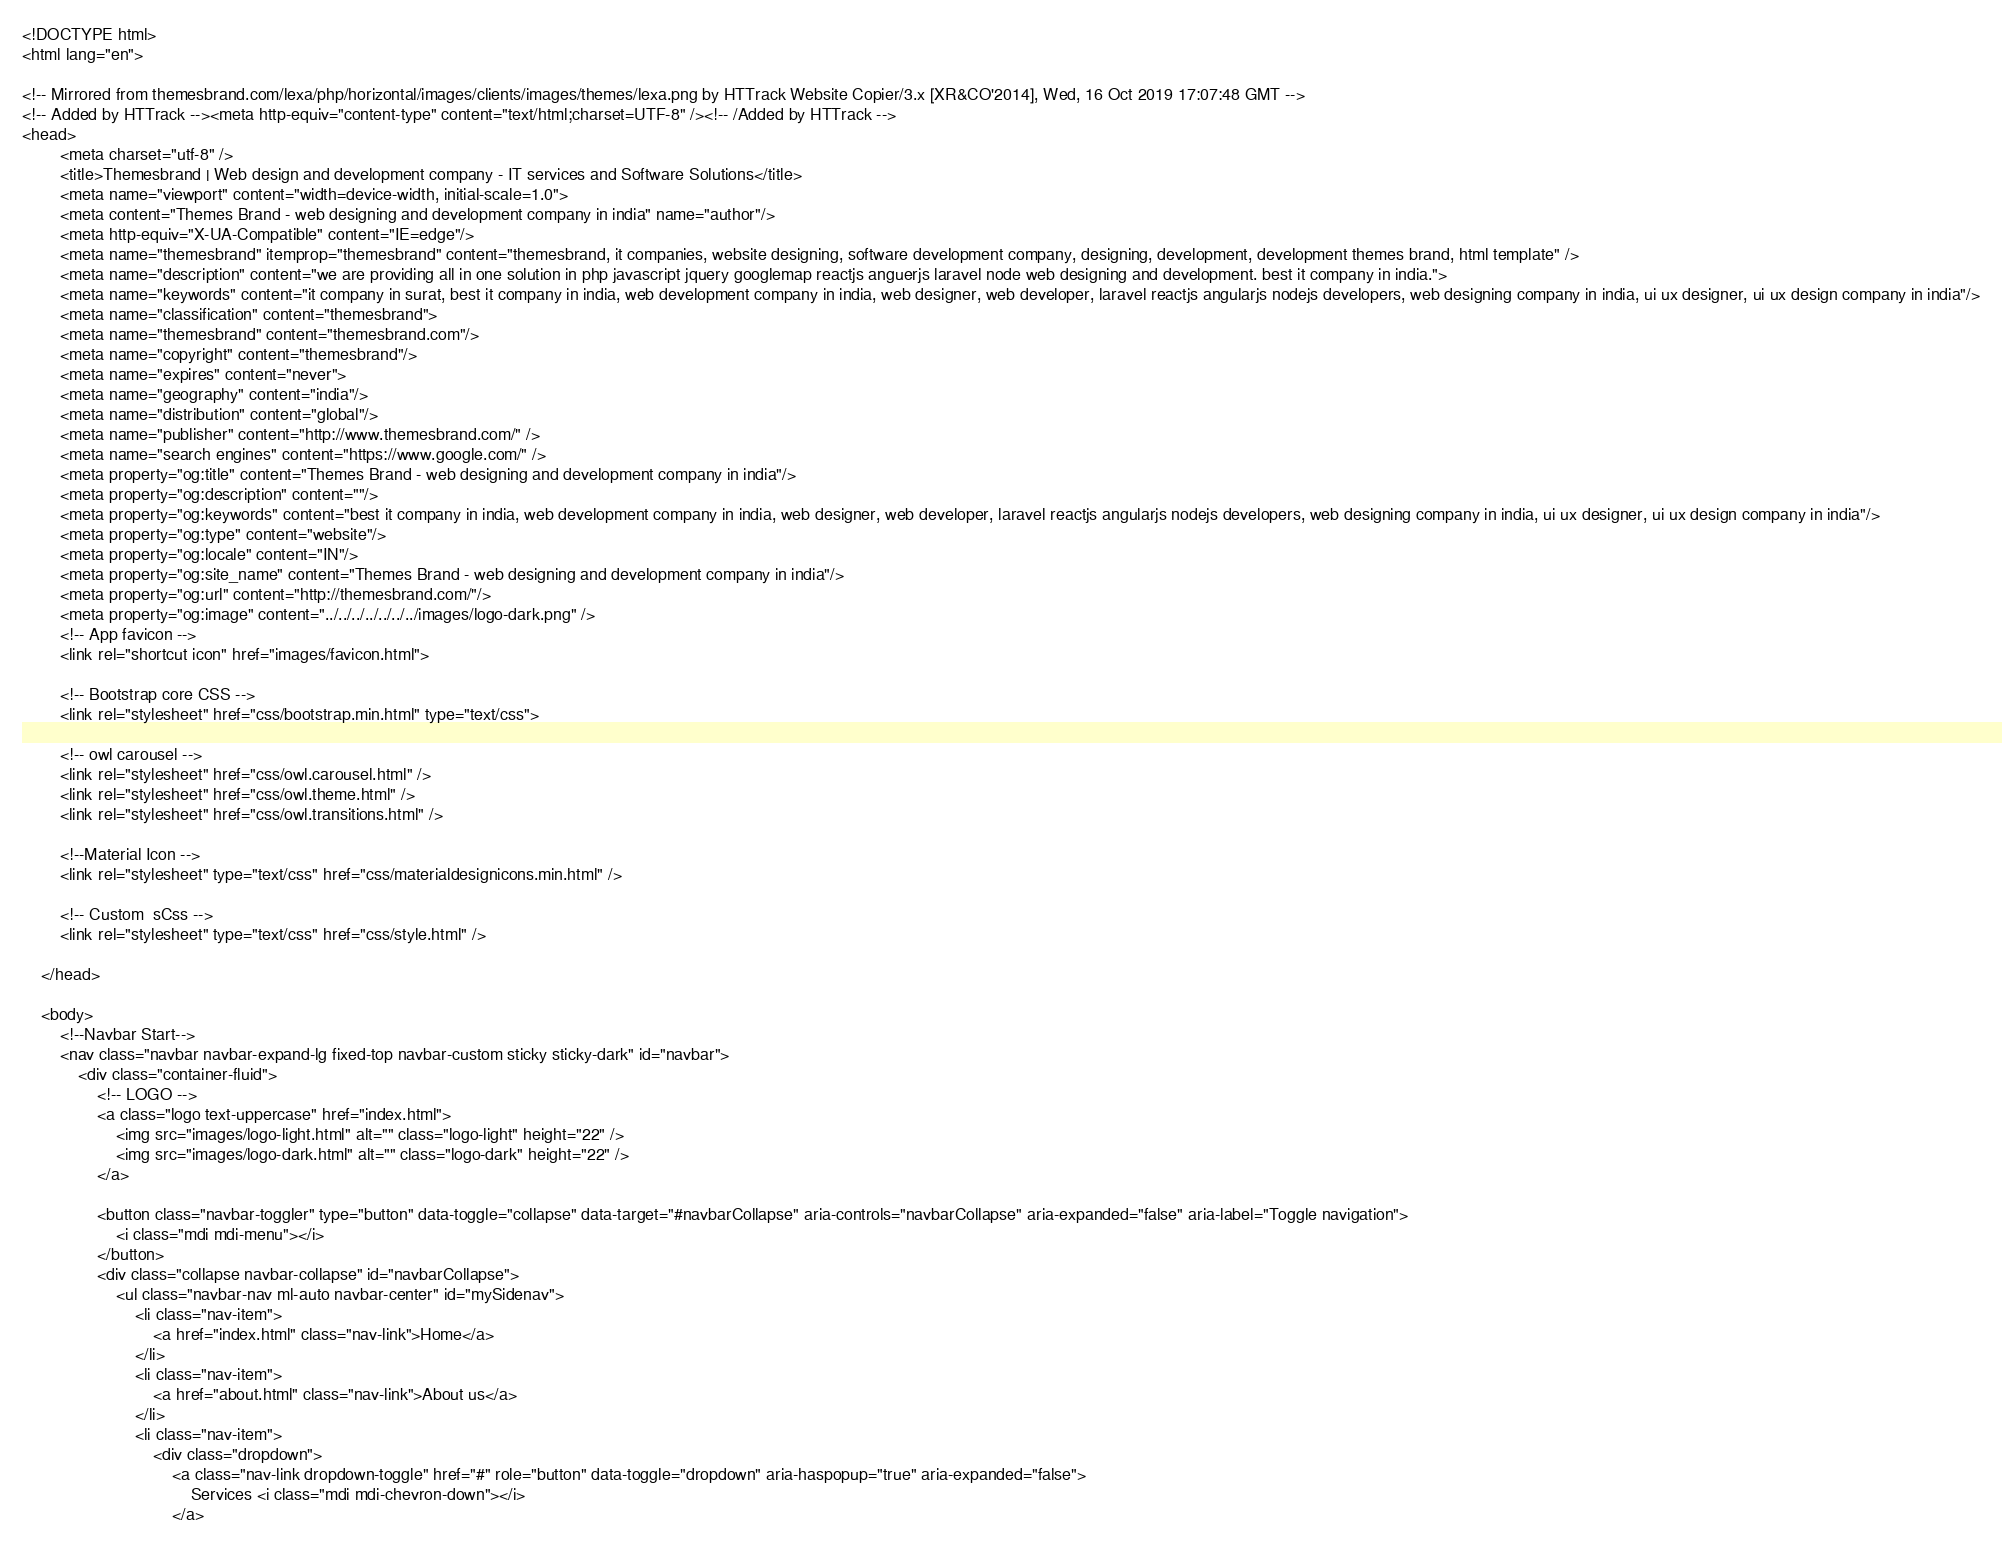Convert code to text. <code><loc_0><loc_0><loc_500><loc_500><_HTML_><!DOCTYPE html>
<html lang="en">
    
<!-- Mirrored from themesbrand.com/lexa/php/horizontal/images/clients/images/themes/lexa.png by HTTrack Website Copier/3.x [XR&CO'2014], Wed, 16 Oct 2019 17:07:48 GMT -->
<!-- Added by HTTrack --><meta http-equiv="content-type" content="text/html;charset=UTF-8" /><!-- /Added by HTTrack -->
<head>
        <meta charset="utf-8" />
        <title>Themesbrand | Web design and development company - IT services and Software Solutions</title>
        <meta name="viewport" content="width=device-width, initial-scale=1.0">
        <meta content="Themes Brand - web designing and development company in india" name="author"/>
        <meta http-equiv="X-UA-Compatible" content="IE=edge"/>
        <meta name="themesbrand" itemprop="themesbrand" content="themesbrand, it companies, website designing, software development company, designing, development, development themes brand, html template" />
        <meta name="description" content="we are providing all in one solution in php javascript jquery googlemap reactjs anguerjs laravel node web designing and development. best it company in india.">
        <meta name="keywords" content="it company in surat, best it company in india, web development company in india, web designer, web developer, laravel reactjs angularjs nodejs developers, web designing company in india, ui ux designer, ui ux design company in india"/>
        <meta name="classification" content="themesbrand">
        <meta name="themesbrand" content="themesbrand.com"/>
        <meta name="copyright" content="themesbrand"/>
        <meta name="expires" content="never">
        <meta name="geography" content="india"/>
        <meta name="distribution" content="global"/>
        <meta name="publisher" content="http://www.themesbrand.com/" />
        <meta name="search engines" content="https://www.google.com/" />
        <meta property="og:title" content="Themes Brand - web designing and development company in india"/>
        <meta property="og:description" content=""/>
        <meta property="og:keywords" content="best it company in india, web development company in india, web designer, web developer, laravel reactjs angularjs nodejs developers, web designing company in india, ui ux designer, ui ux design company in india"/>
        <meta property="og:type" content="website"/>
        <meta property="og:locale" content="IN"/>
        <meta property="og:site_name" content="Themes Brand - web designing and development company in india"/>
        <meta property="og:url" content="http://themesbrand.com/"/>
        <meta property="og:image" content="../../../../../../../images/logo-dark.png" />
        <!-- App favicon -->
        <link rel="shortcut icon" href="images/favicon.html">

        <!-- Bootstrap core CSS -->
        <link rel="stylesheet" href="css/bootstrap.min.html" type="text/css">

        <!-- owl carousel -->
        <link rel="stylesheet" href="css/owl.carousel.html" />
        <link rel="stylesheet" href="css/owl.theme.html" />
        <link rel="stylesheet" href="css/owl.transitions.html" />

        <!--Material Icon -->
        <link rel="stylesheet" type="text/css" href="css/materialdesignicons.min.html" />

        <!-- Custom  sCss -->
        <link rel="stylesheet" type="text/css" href="css/style.html" />

    </head>

    <body>
        <!--Navbar Start-->
        <nav class="navbar navbar-expand-lg fixed-top navbar-custom sticky sticky-dark" id="navbar">
            <div class="container-fluid">
                <!-- LOGO -->
                <a class="logo text-uppercase" href="index.html">
                    <img src="images/logo-light.html" alt="" class="logo-light" height="22" />
                    <img src="images/logo-dark.html" alt="" class="logo-dark" height="22" />
                </a>

                <button class="navbar-toggler" type="button" data-toggle="collapse" data-target="#navbarCollapse" aria-controls="navbarCollapse" aria-expanded="false" aria-label="Toggle navigation">
                    <i class="mdi mdi-menu"></i>
                </button>
                <div class="collapse navbar-collapse" id="navbarCollapse">
                    <ul class="navbar-nav ml-auto navbar-center" id="mySidenav">
                        <li class="nav-item">
                            <a href="index.html" class="nav-link">Home</a>
                        </li>
                        <li class="nav-item">
                            <a href="about.html" class="nav-link">About us</a>
                        </li>
                        <li class="nav-item">
                            <div class="dropdown">
                                <a class="nav-link dropdown-toggle" href="#" role="button" data-toggle="dropdown" aria-haspopup="true" aria-expanded="false">
                                    Services <i class="mdi mdi-chevron-down"></i>
                                </a></code> 